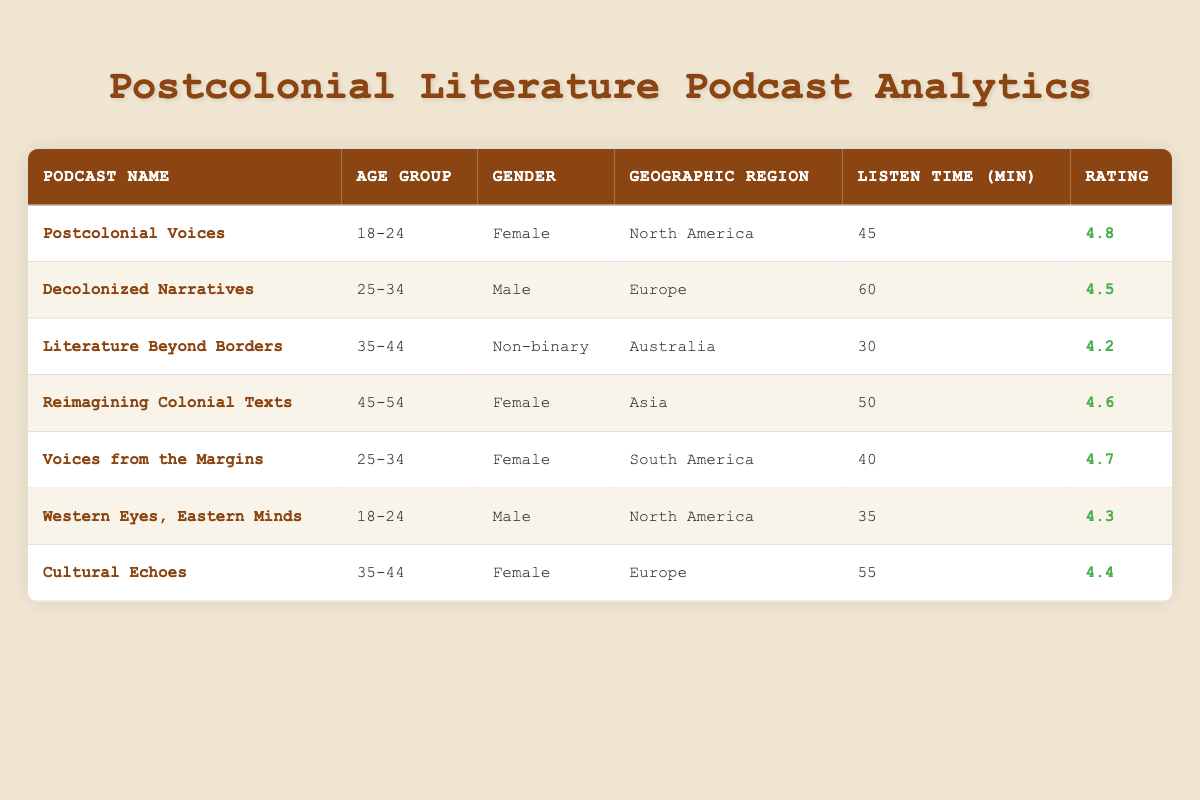What is the average listen time per episode for the 'Postcolonial Voices' podcast? The listen time for 'Postcolonial Voices' is given as 45 minutes. Thus, the average listen time for this specific podcast is simply the value provided.
Answer: 45 Which podcast has the highest episode rating? By evaluating the 'Rating' column, the podcast 'Postcolonial Voices' has a rating of 4.8, which is the highest among all the podcasts listed.
Answer: Postcolonial Voices Are there any podcasts with a listen time of over 50 minutes? Checking the 'Listen Time' column, both 'Decolonized Narratives' (60 minutes) and 'Cultural Echoes' (55 minutes) list listen times above 50 minutes, indicating that there are indeed podcasts meeting this criterion.
Answer: Yes What is the total listen time for podcasts that are categorized as 'Female' gender? The listen times for the 'Female' gender podcasts are as follows: 'Postcolonial Voices' (45), 'Reimagining Colonial Texts' (50), 'Voices from the Margins' (40), and 'Cultural Echoes' (55). Adding these values results in 45 + 50 + 40 + 55 = 190 minutes. Therefore, the total listen time for all podcasts categorized under 'Female' gender is 190 minutes.
Answer: 190 Is there a podcast in the 35-44 age group that has a rating of 4.5 or higher? Reviewing the age group and rating columns, both 'Literature Beyond Borders' (4.2) and 'Cultural Echoes' (4.4) are in the 35-44 age group, but only 'Cultural Echoes' has a rating lower than 4.5 (4.4). Therefore, the answer is no.
Answer: No What is the average episode rating for podcasts from North America? The North American podcasts listed are 'Postcolonial Voices' (4.8) and 'Western Eyes, Eastern Minds' (4.3). To calculate the average, sum the ratings (4.8 + 4.3 = 9.1) and divide by the number of podcasts (2): 9.1 / 2 = 4.55. Thus, the average episode rating for podcasts from North America is 4.55.
Answer: 4.55 Which geographic region has the most podcasts listed? By counting the occurrences in the 'Geographic Region' column, North America has 2 podcasts, Europe has 2, Australia has 1, Asia has 1, and South America has 1. Both North America and Europe have the highest count, with 2 podcasts each.
Answer: North America and Europe What age group has a podcast with the lowest episode rating? By analyzing the ratings, 'Literature Beyond Borders' is in the 35-44 age group and has the lowest rating, which is 4.2 when compared with other age group podcasts. Thus, the 35-44 age group contains the podcast with the lowest rating.
Answer: 35-44 